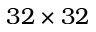Convert formula to latex. <formula><loc_0><loc_0><loc_500><loc_500>3 2 \times 3 2</formula> 